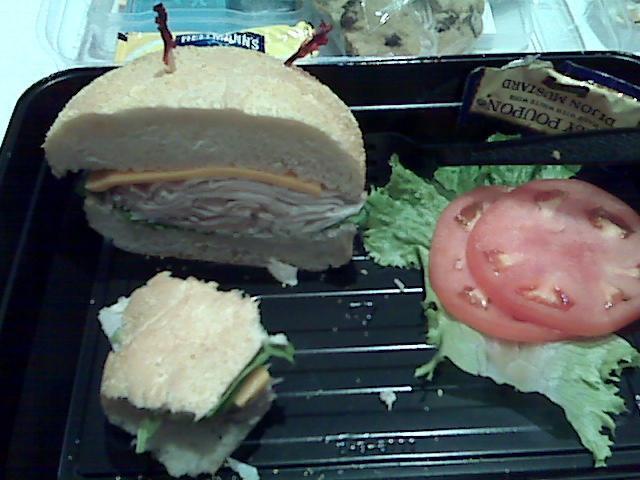How many sandwiches can you see?
Give a very brief answer. 2. How many trains have a number on the front?
Give a very brief answer. 0. 